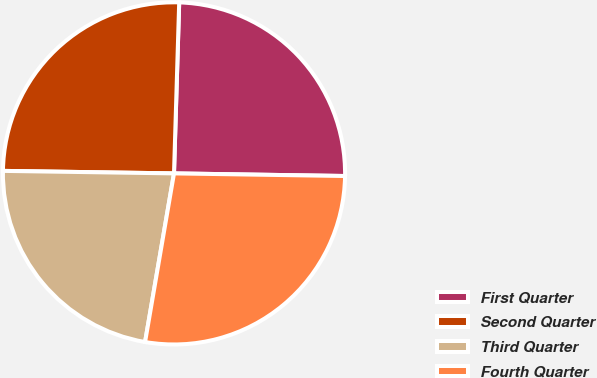<chart> <loc_0><loc_0><loc_500><loc_500><pie_chart><fcel>First Quarter<fcel>Second Quarter<fcel>Third Quarter<fcel>Fourth Quarter<nl><fcel>24.76%<fcel>25.25%<fcel>22.53%<fcel>27.46%<nl></chart> 